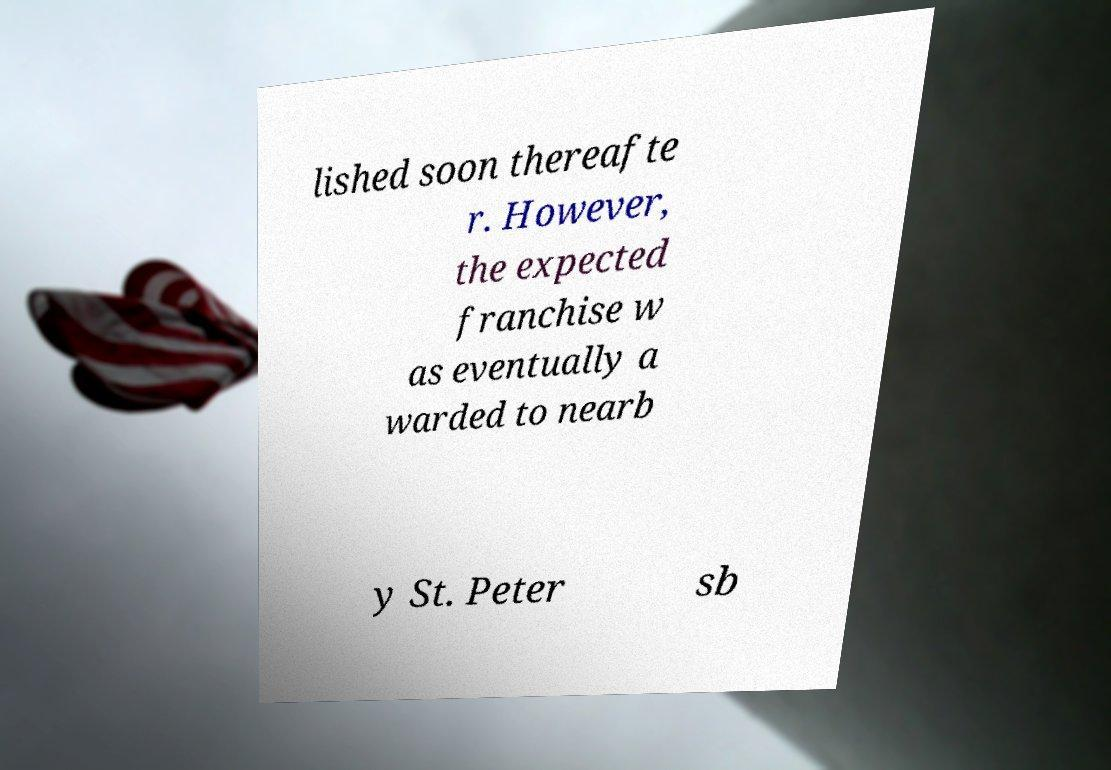There's text embedded in this image that I need extracted. Can you transcribe it verbatim? lished soon thereafte r. However, the expected franchise w as eventually a warded to nearb y St. Peter sb 